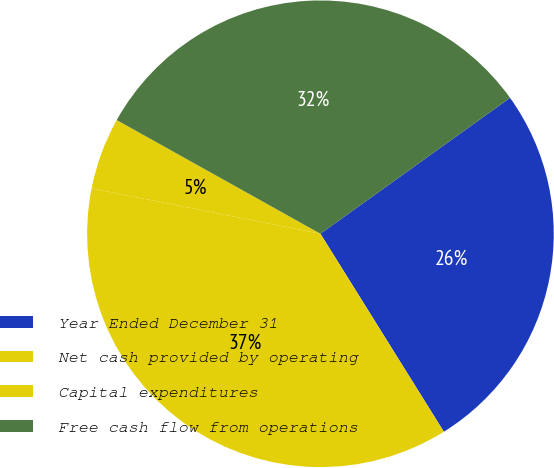<chart> <loc_0><loc_0><loc_500><loc_500><pie_chart><fcel>Year Ended December 31<fcel>Net cash provided by operating<fcel>Capital expenditures<fcel>Free cash flow from operations<nl><fcel>26.03%<fcel>36.99%<fcel>4.99%<fcel>32.0%<nl></chart> 